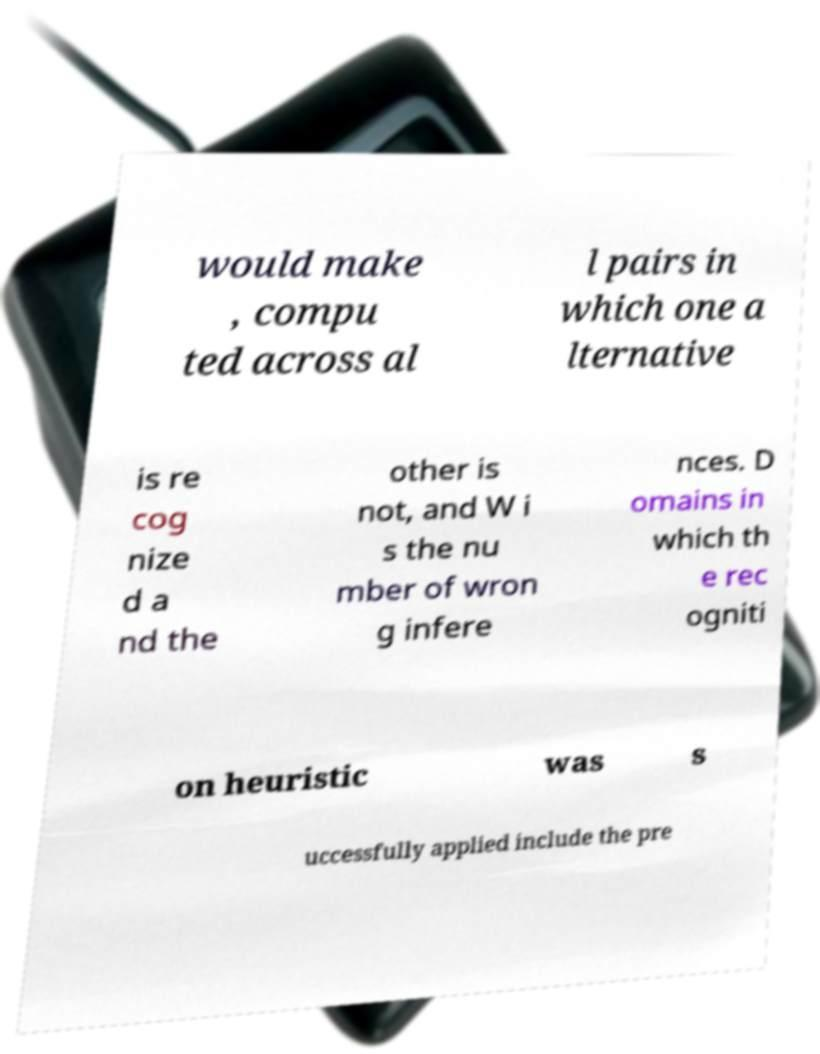For documentation purposes, I need the text within this image transcribed. Could you provide that? would make , compu ted across al l pairs in which one a lternative is re cog nize d a nd the other is not, and W i s the nu mber of wron g infere nces. D omains in which th e rec ogniti on heuristic was s uccessfully applied include the pre 